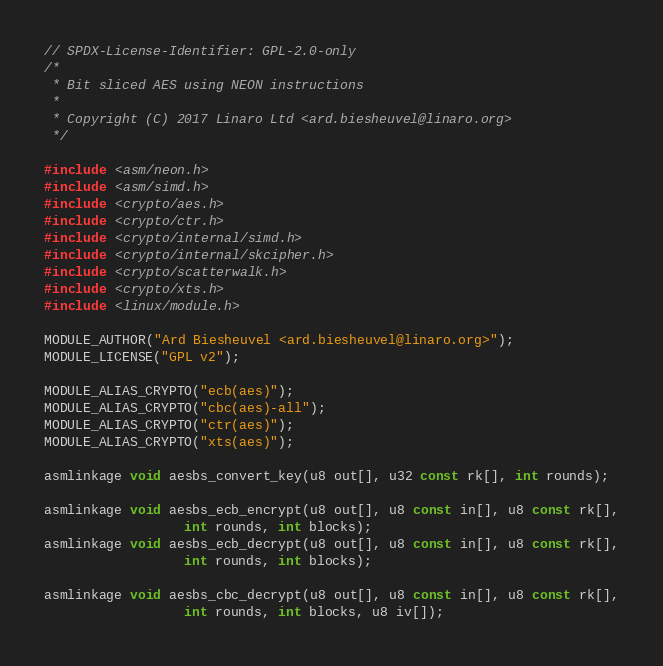<code> <loc_0><loc_0><loc_500><loc_500><_C_>// SPDX-License-Identifier: GPL-2.0-only
/*
 * Bit sliced AES using NEON instructions
 *
 * Copyright (C) 2017 Linaro Ltd <ard.biesheuvel@linaro.org>
 */

#include <asm/neon.h>
#include <asm/simd.h>
#include <crypto/aes.h>
#include <crypto/ctr.h>
#include <crypto/internal/simd.h>
#include <crypto/internal/skcipher.h>
#include <crypto/scatterwalk.h>
#include <crypto/xts.h>
#include <linux/module.h>

MODULE_AUTHOR("Ard Biesheuvel <ard.biesheuvel@linaro.org>");
MODULE_LICENSE("GPL v2");

MODULE_ALIAS_CRYPTO("ecb(aes)");
MODULE_ALIAS_CRYPTO("cbc(aes)-all");
MODULE_ALIAS_CRYPTO("ctr(aes)");
MODULE_ALIAS_CRYPTO("xts(aes)");

asmlinkage void aesbs_convert_key(u8 out[], u32 const rk[], int rounds);

asmlinkage void aesbs_ecb_encrypt(u8 out[], u8 const in[], u8 const rk[],
				  int rounds, int blocks);
asmlinkage void aesbs_ecb_decrypt(u8 out[], u8 const in[], u8 const rk[],
				  int rounds, int blocks);

asmlinkage void aesbs_cbc_decrypt(u8 out[], u8 const in[], u8 const rk[],
				  int rounds, int blocks, u8 iv[]);
</code> 